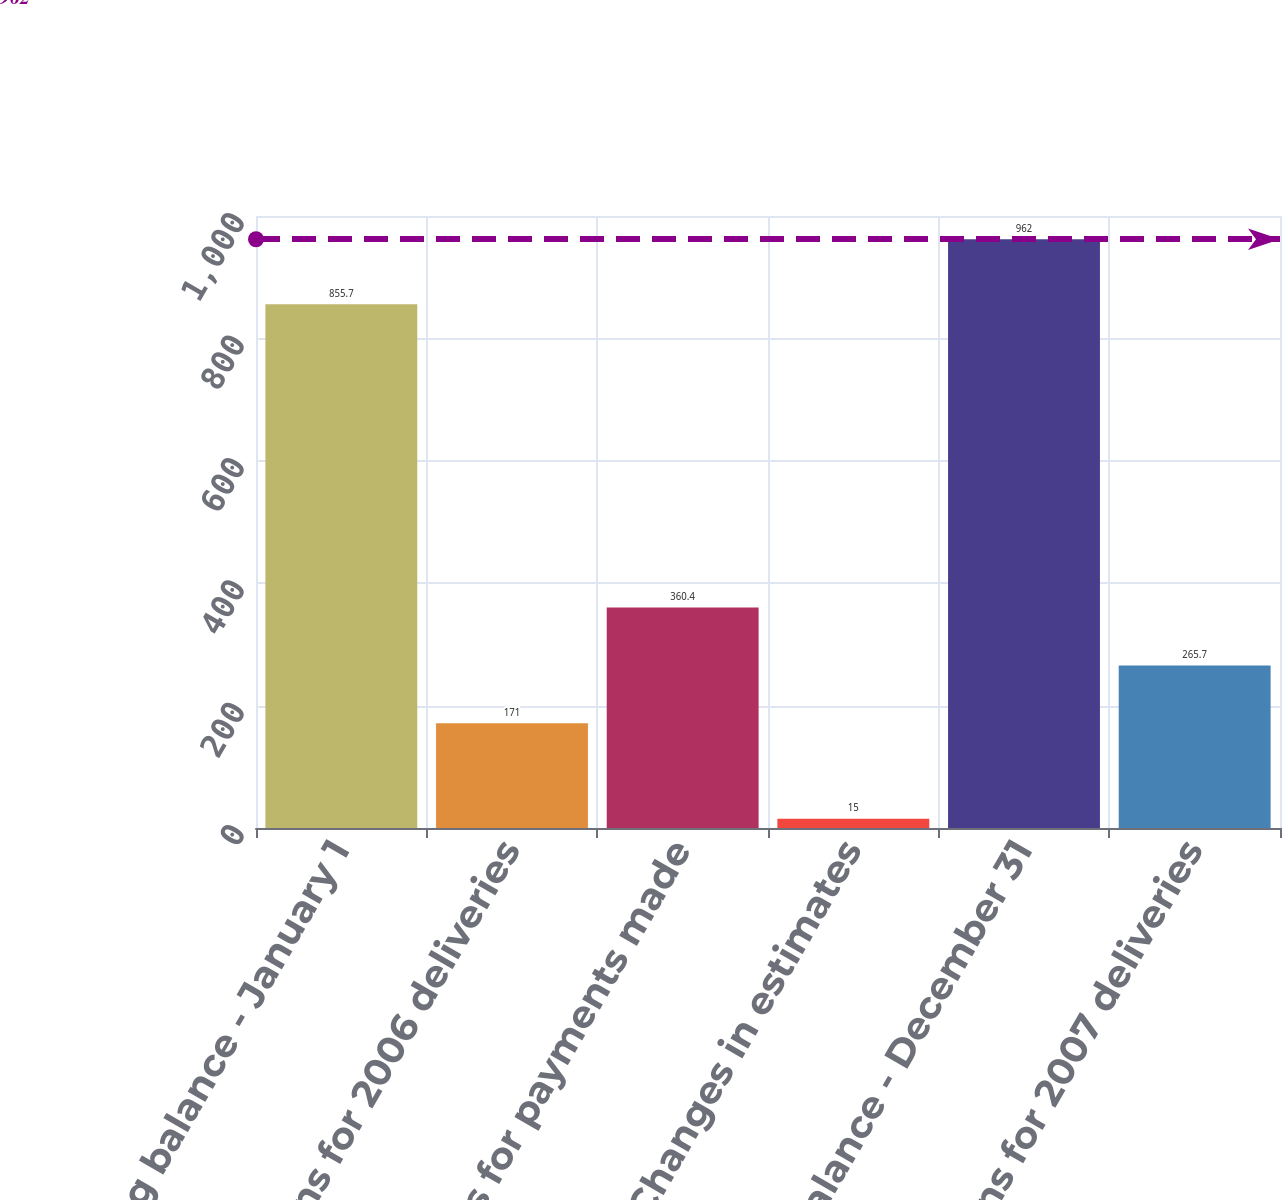Convert chart. <chart><loc_0><loc_0><loc_500><loc_500><bar_chart><fcel>Beginning balance - January 1<fcel>Additions for 2006 deliveries<fcel>Reductions for payments made<fcel>Changes in estimates<fcel>Ending balance - December 31<fcel>Additions for 2007 deliveries<nl><fcel>855.7<fcel>171<fcel>360.4<fcel>15<fcel>962<fcel>265.7<nl></chart> 